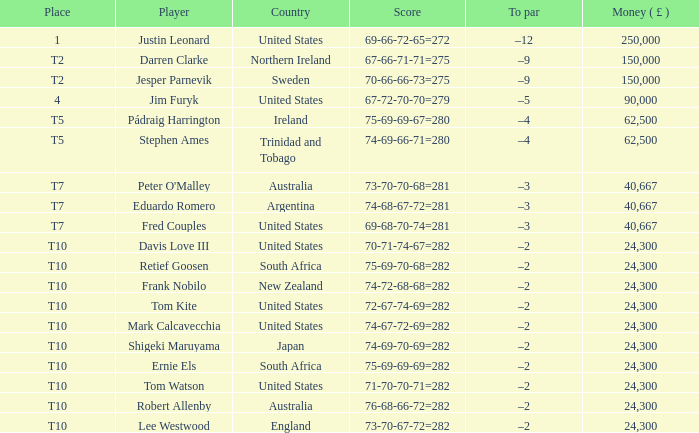What is the money won by Frank Nobilo? 1.0. 